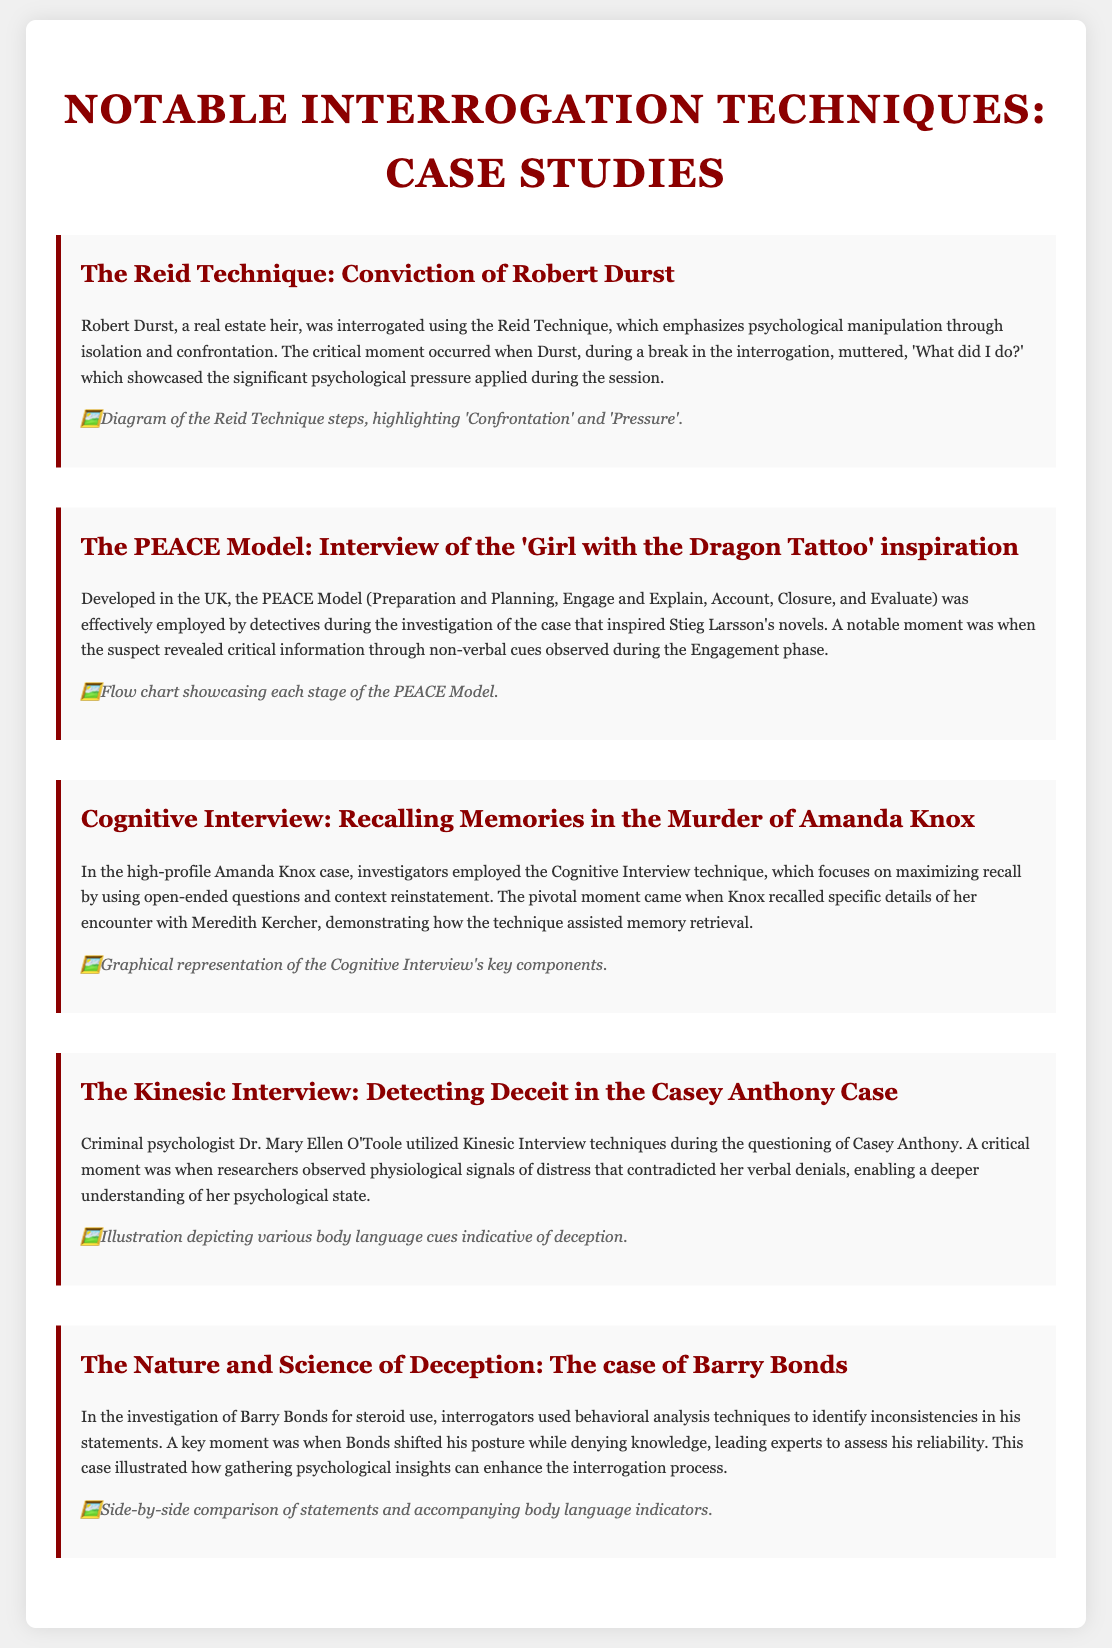What technique was used in the conviction of Robert Durst? The document mentions that the Reid Technique was utilized for Robert Durst's interrogation.
Answer: Reid Technique What critical moment occurred during the Reid Technique interrogation? It is noted that Durst muttered, 'What did I do?' during a break in the interrogation.
Answer: 'What did I do?' What does the PEACE Model stand for? The acronym PEACE represents Preparation and Planning, Engage and Explain, Account, Closure, and Evaluate.
Answer: Preparation and Planning, Engage and Explain, Account, Closure, and Evaluate In which high-profile case was the Cognitive Interview technique used? The Cognitive Interview technique was employed in the Amanda Knox case, as mentioned in the document.
Answer: Amanda Knox Which psychologist utilized Kinesic Interview techniques in the Casey Anthony case? The document states that Dr. Mary Ellen O'Toole used Kinesic Interview techniques during the Casey Anthony interrogation.
Answer: Dr. Mary Ellen O'Toole What was the key behavioral indicator identified during Barry Bonds' interrogation? The document highlights that Bonds shifted his posture while denying knowledge as a behavioral indicator.
Answer: Shifted posture What is a notable feature of the illustration accompanying the Kinesic Interview case study? The illustration depicts various body language cues indicative of deception, according to the document.
Answer: Body language cues How many notable interrogation techniques are detailed in the document? The document provides details on five notable interrogation techniques used by criminal psychologists.
Answer: Five 